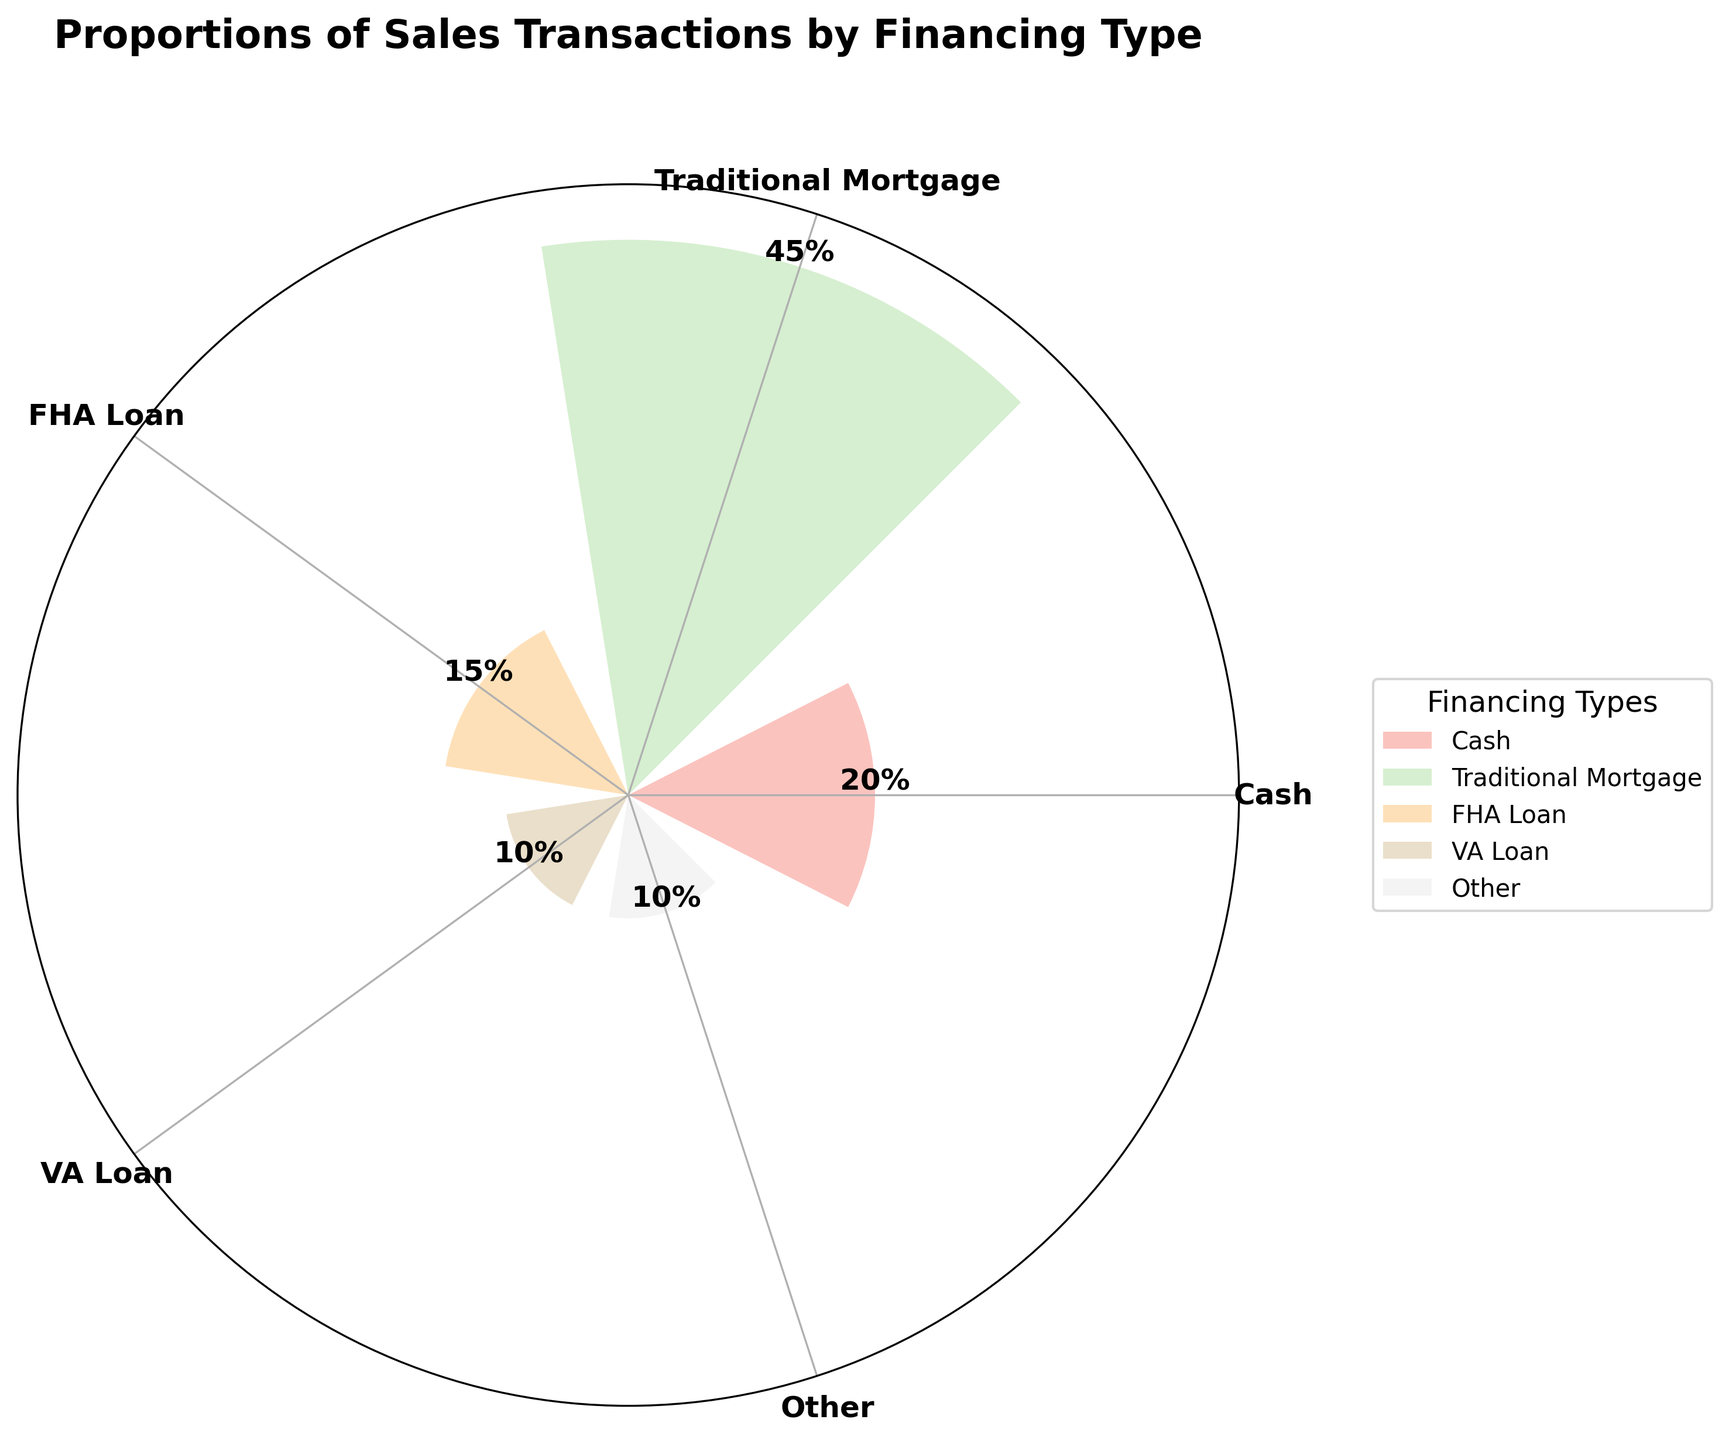What is the title of the plot? The title is usually displayed at the top of the plot. In this case, it is set clearly above the rose chart.
Answer: Proportions of Sales Transactions by Financing Type What financing type has the highest proportion of sales transactions? By looking at the height of the bars in the rose chart, you can identify the longest bar which corresponds to Traditional Mortgage.
Answer: Traditional Mortgage What is the proportion of sales for FHA loans? This information is shown directly on the bar for FHA loans. You can read the label above that bar.
Answer: 15% Which two financing types have the same proportion of sales transactions? By observing the lengths of the bars, you can see that VA Loan and Other both extend to the same length and have the same proportion.
Answer: VA Loan and Other What is the total proportion of sales transactions for Cash and Traditional Mortgage combined? Add the proportions of Cash and Traditional Mortgage from the chart: 20% + 45%.
Answer: 65% What is the least common type of financing used based on the proportion of sales? The shortest bar in the rose chart represents the least common type, which is VA Loan (equal to Other but considered here as it appears later in data order).
Answer: VA Loan How many types of financing are represented in the chart? Count the number of different bars or labels on the chart, each corresponding to a financing type.
Answer: 5 Which type of financing is more common: FHA Loan or VA Loan? Compare the lengths of the bars for FHA Loan and VA Loan. The FHA Loan bar is longer.
Answer: FHA Loan What is the difference in the proportion of sales between Cash and VA Loans? Subtract the proportion of VA Loans from the proportion of Cash: 20% - 10%.
Answer: 10% If you combine the proportions of sales from FHA Loan, VA Loan, and Other, what is the result? Add the proportions of FHA Loan, VA Loan, and Other: 15% + 10% + 10%.
Answer: 35% 